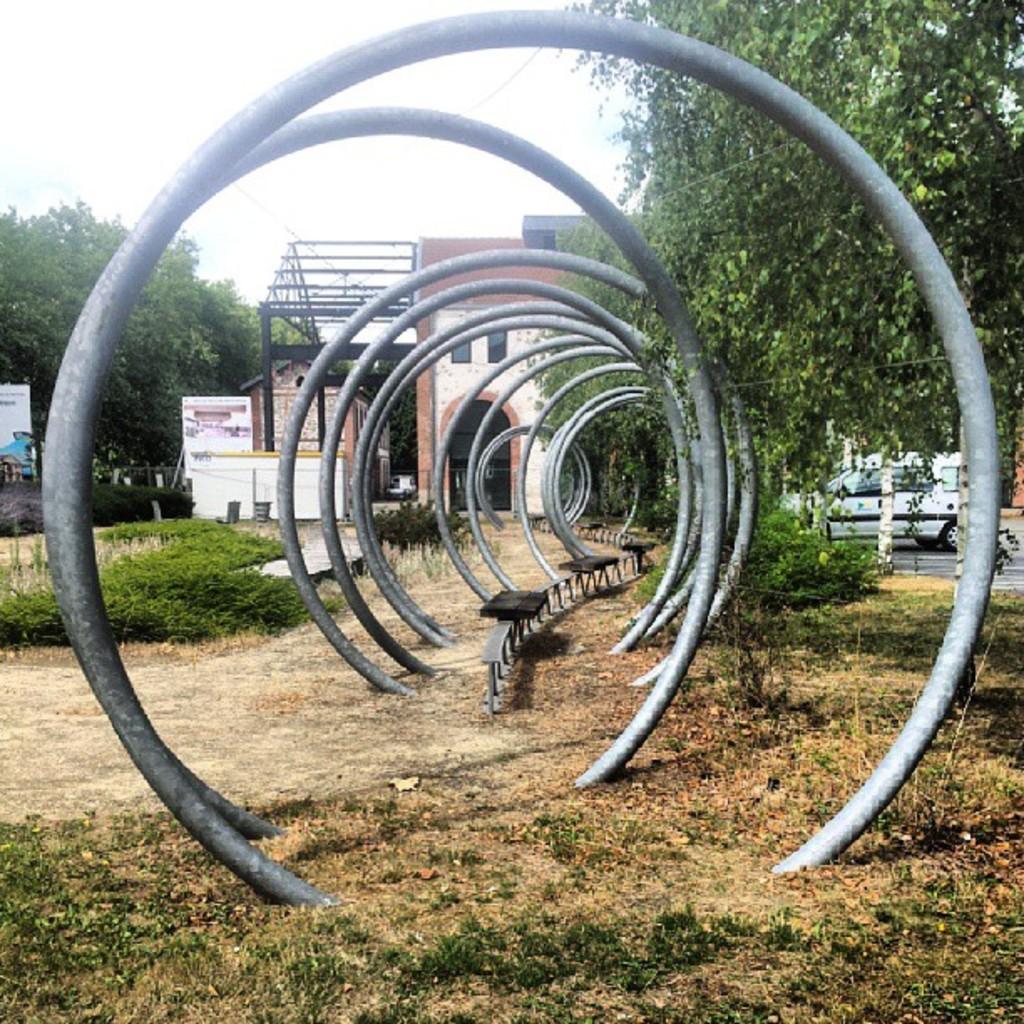Describe this image in one or two sentences. In this picture we can see circular metal objects, benches, grass, trees, board, buildings, vehicle and trees. In the background of the image we can see the sky. 